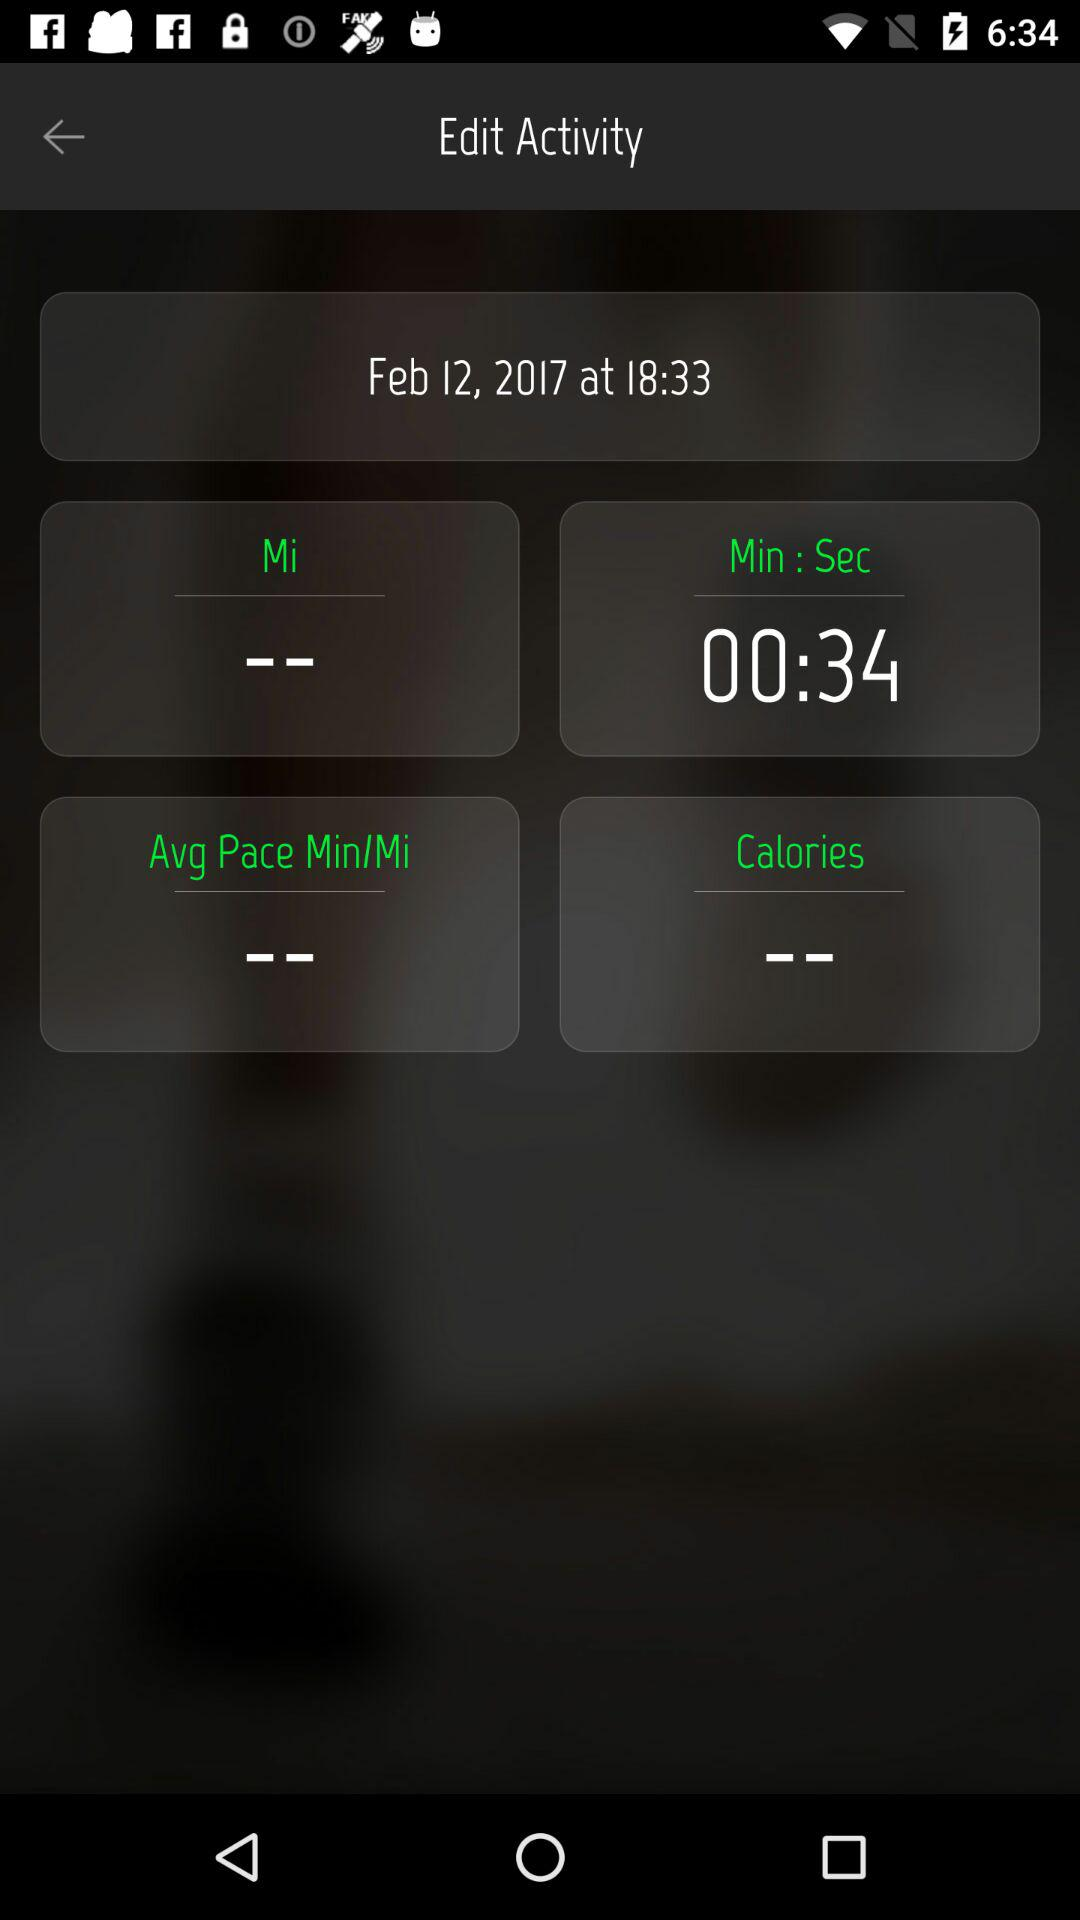What is the given duration? The given duration is 34 seconds. 